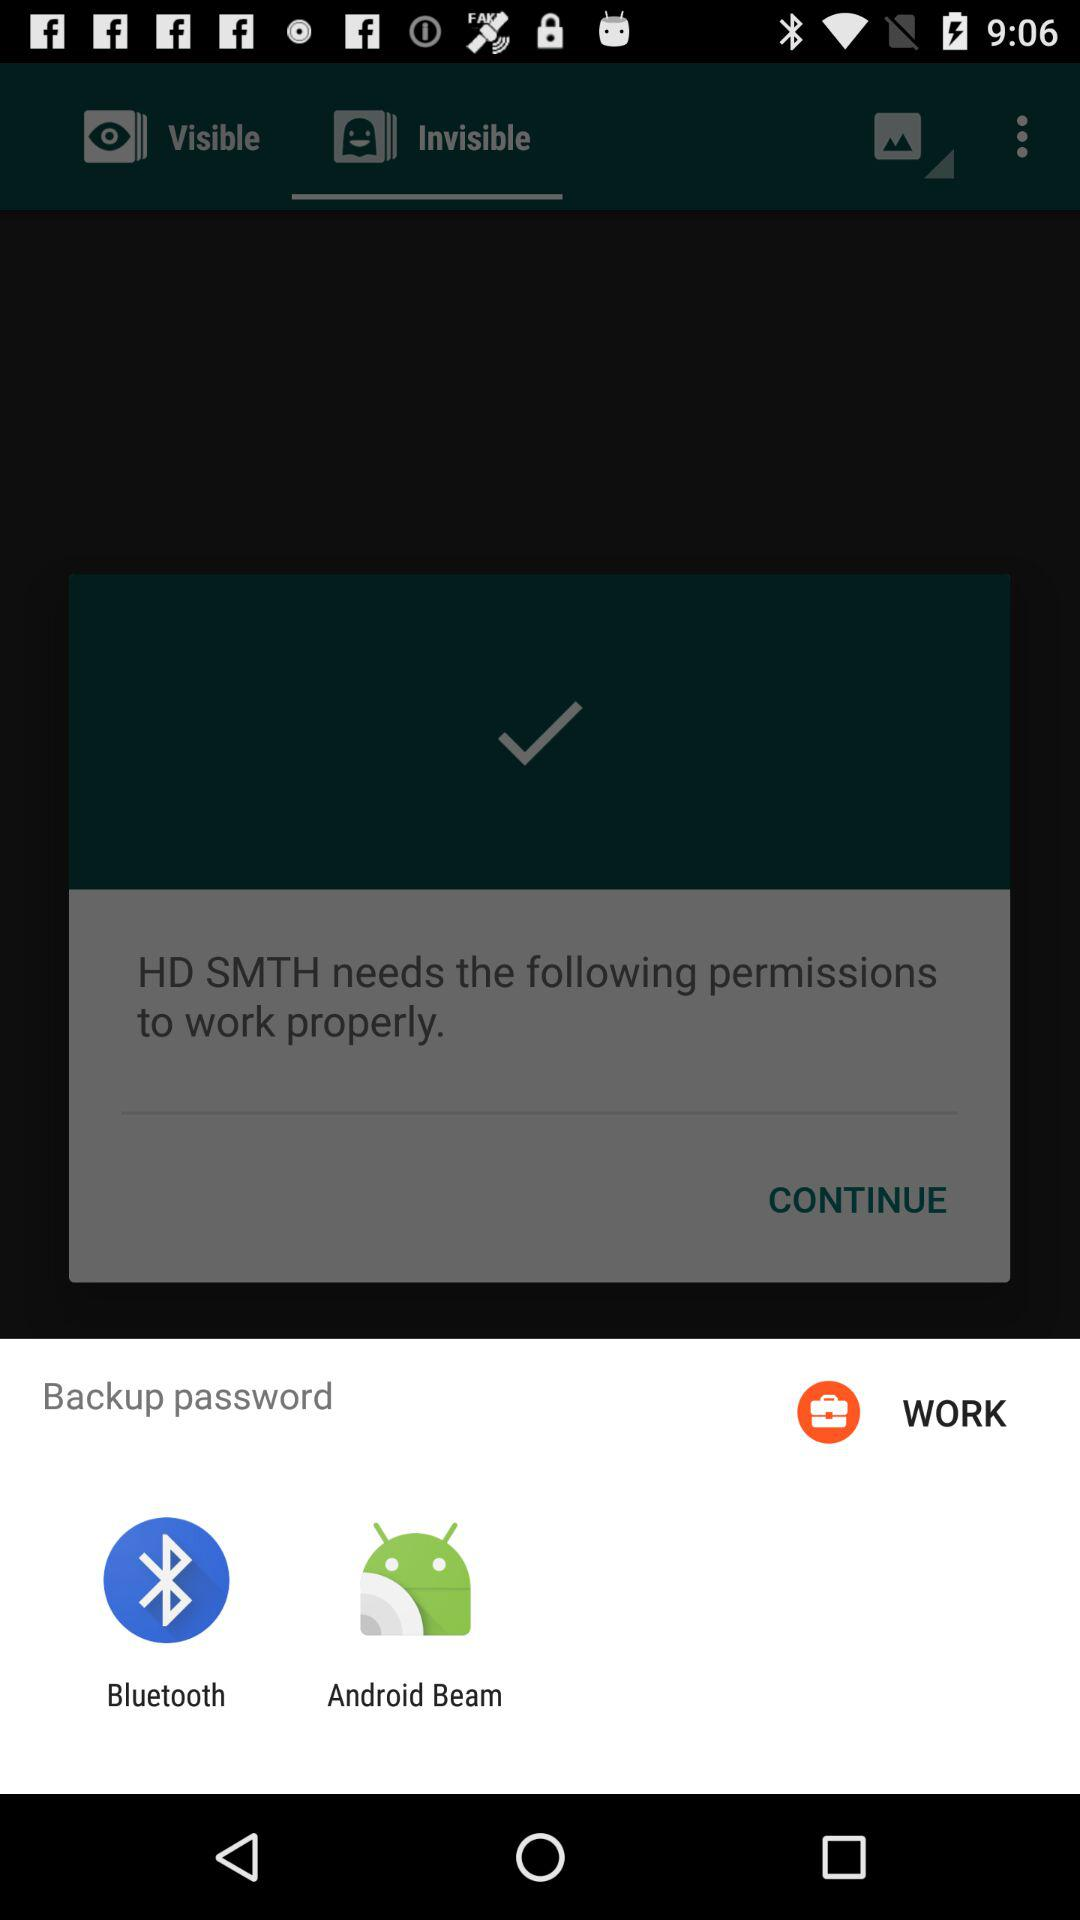Which options are given for backing up the password? The options are "Bluetooth" and "Android Beam". 